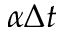<formula> <loc_0><loc_0><loc_500><loc_500>\alpha \Delta t</formula> 